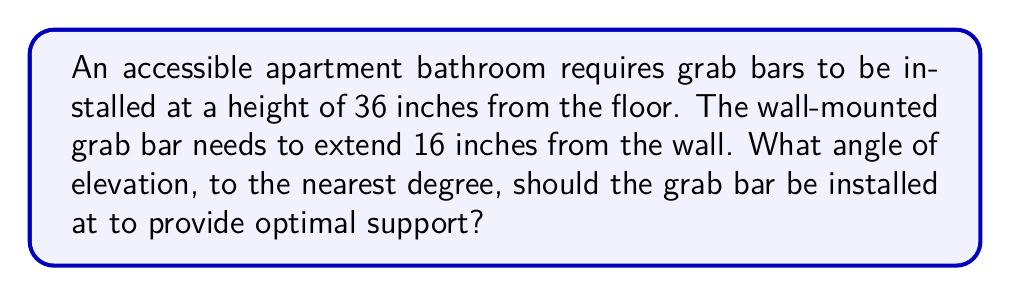Can you solve this math problem? Let's approach this step-by-step:

1) We can visualize this as a right-angled triangle, where:
   - The vertical height is 36 inches
   - The horizontal distance (extension from the wall) is 16 inches
   - The angle of elevation is what we're trying to find

2) In this right-angled triangle, we know the opposite (height) and adjacent (extension) sides, and we need to find the angle.

3) This scenario calls for the use of the arctangent (tan^(-1) or atan) function.

4) The formula for tangent in a right-angled triangle is:

   $$\tan(\theta) = \frac{\text{opposite}}{\text{adjacent}}$$

5) Substituting our values:

   $$\tan(\theta) = \frac{36}{16} = 2.25$$

6) To find θ, we take the arctangent of both sides:

   $$\theta = \tan^{-1}(2.25)$$

7) Using a calculator or trigonometric tables:

   $$\theta \approx 66.0375^{\circ}$$

8) Rounding to the nearest degree:

   $$\theta \approx 66^{\circ}$$

[asy]
import geometry;

size(200);

pair A = (0,0), B = (16,0), C = (0,36);
draw(A--B--C--A);
draw(rightanglemark(A,B,C,8));

label("36\"", C--A, W);
label("16\"", A--B, S);
label("$\theta$", A, SE);

dot("A", A, SW);
dot("B", B, SE);
dot("C", C, NW);
[/asy]
Answer: $66^{\circ}$ 